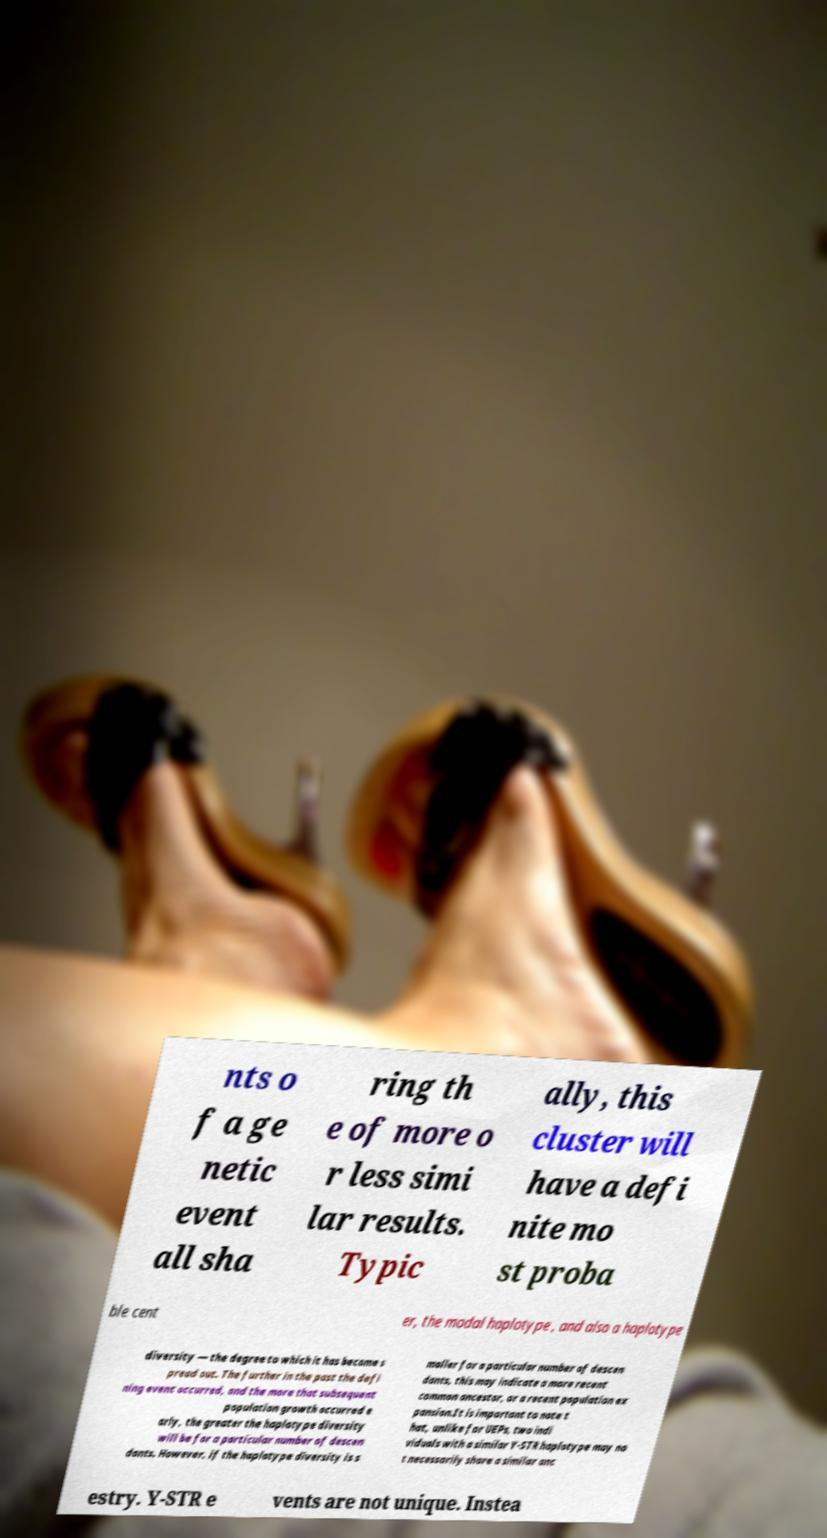Can you read and provide the text displayed in the image?This photo seems to have some interesting text. Can you extract and type it out for me? nts o f a ge netic event all sha ring th e of more o r less simi lar results. Typic ally, this cluster will have a defi nite mo st proba ble cent er, the modal haplotype , and also a haplotype diversity — the degree to which it has become s pread out. The further in the past the defi ning event occurred, and the more that subsequent population growth occurred e arly, the greater the haplotype diversity will be for a particular number of descen dants. However, if the haplotype diversity is s maller for a particular number of descen dants, this may indicate a more recent common ancestor, or a recent population ex pansion.It is important to note t hat, unlike for UEPs, two indi viduals with a similar Y-STR haplotype may no t necessarily share a similar anc estry. Y-STR e vents are not unique. Instea 